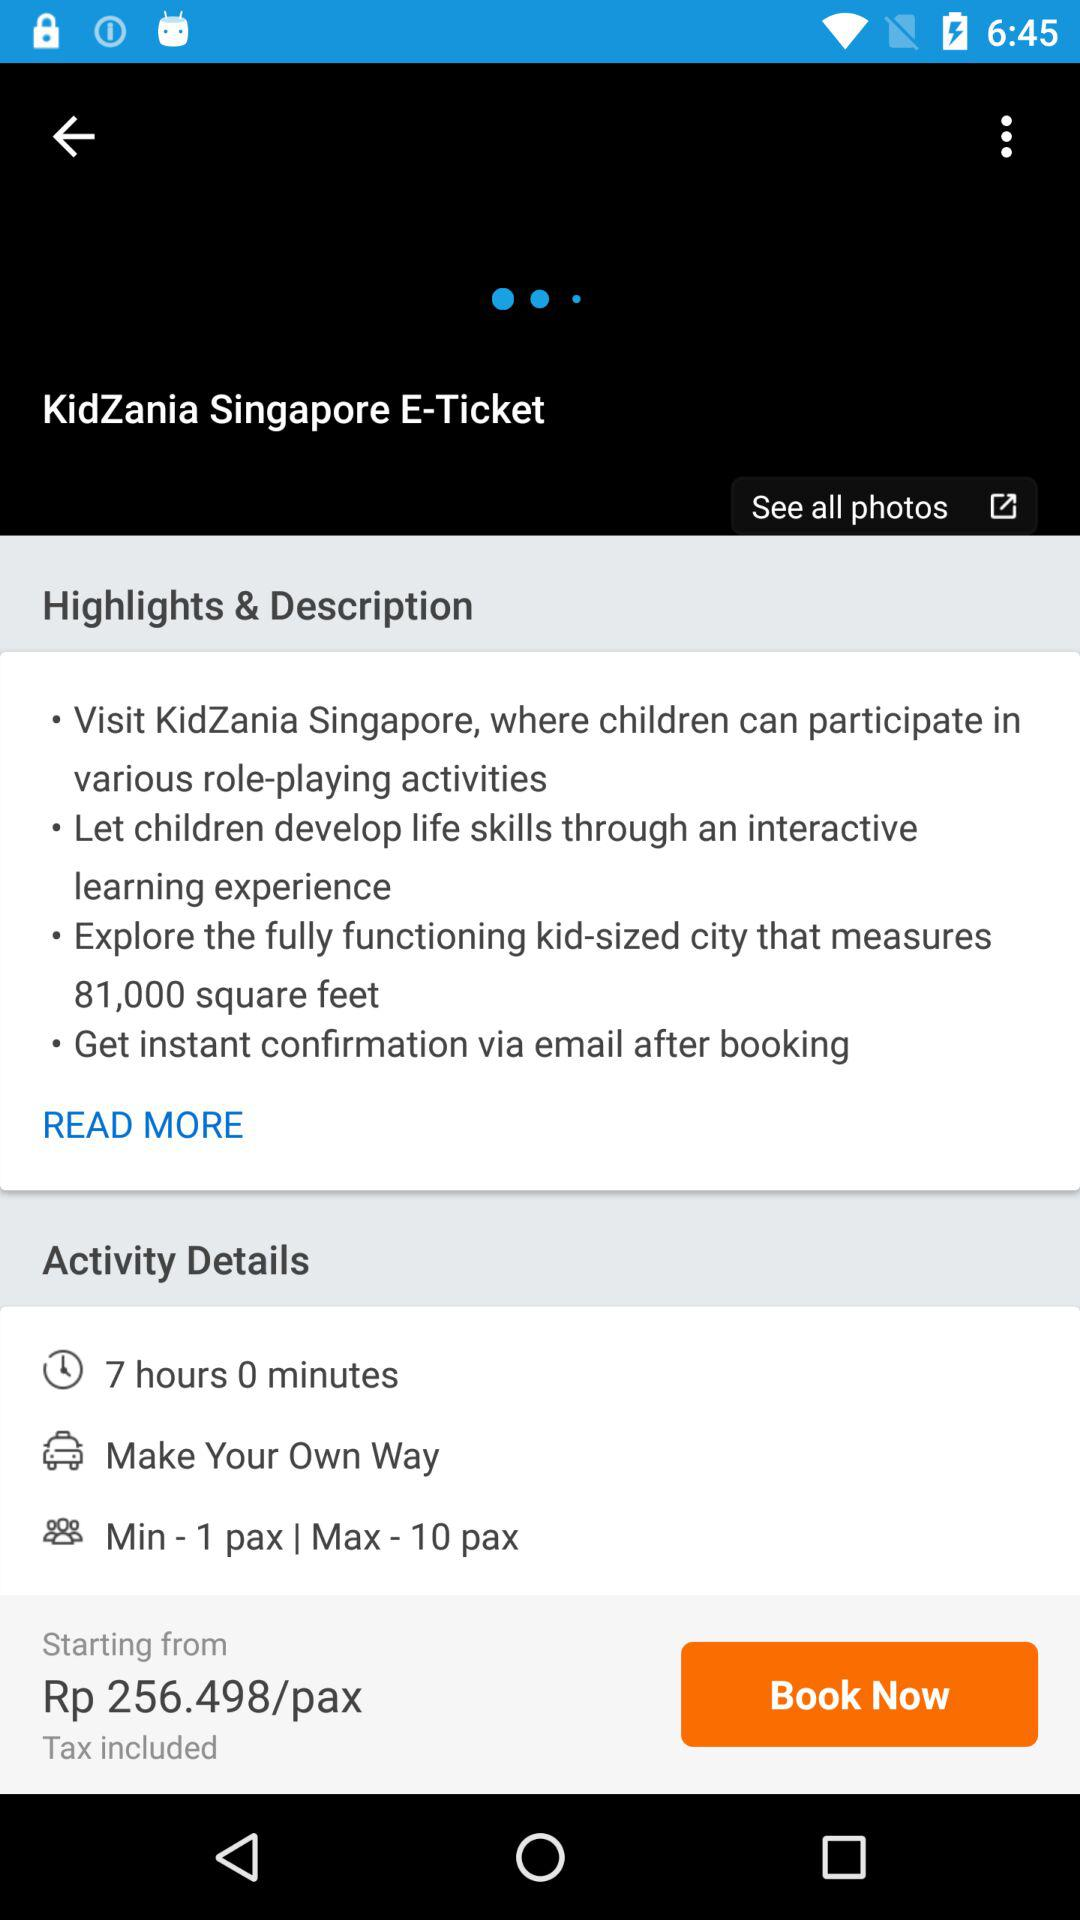What's the starting price per pax? The starting price per pax is Rp 256.498. 